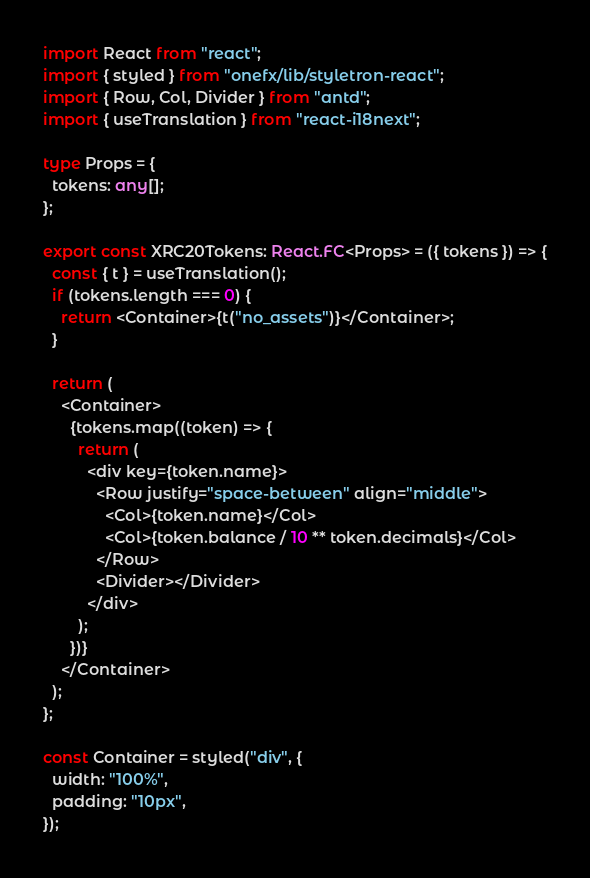<code> <loc_0><loc_0><loc_500><loc_500><_TypeScript_>import React from "react";
import { styled } from "onefx/lib/styletron-react";
import { Row, Col, Divider } from "antd";
import { useTranslation } from "react-i18next";

type Props = {
  tokens: any[];
};

export const XRC20Tokens: React.FC<Props> = ({ tokens }) => {
  const { t } = useTranslation();
  if (tokens.length === 0) {
    return <Container>{t("no_assets")}</Container>;
  }

  return (
    <Container>
      {tokens.map((token) => {
        return (
          <div key={token.name}>
            <Row justify="space-between" align="middle">
              <Col>{token.name}</Col>
              <Col>{token.balance / 10 ** token.decimals}</Col>
            </Row>
            <Divider></Divider>
          </div>
        );
      })}
    </Container>
  );
};

const Container = styled("div", {
  width: "100%",
  padding: "10px",
});
</code> 